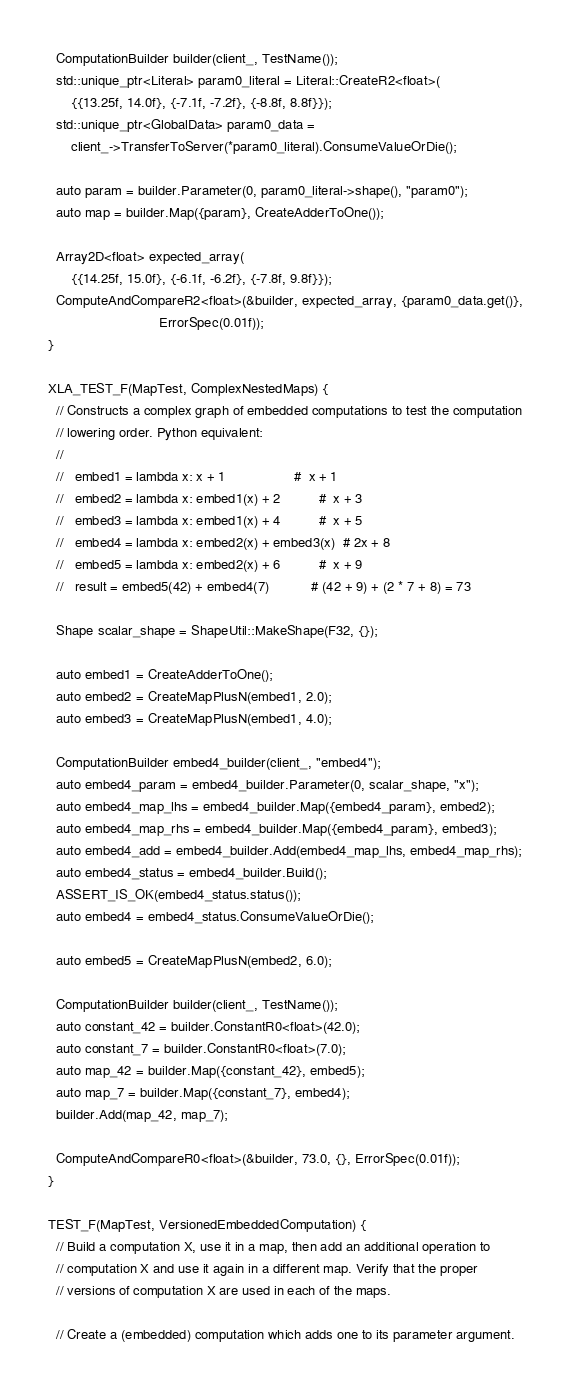<code> <loc_0><loc_0><loc_500><loc_500><_C++_>  ComputationBuilder builder(client_, TestName());
  std::unique_ptr<Literal> param0_literal = Literal::CreateR2<float>(
      {{13.25f, 14.0f}, {-7.1f, -7.2f}, {-8.8f, 8.8f}});
  std::unique_ptr<GlobalData> param0_data =
      client_->TransferToServer(*param0_literal).ConsumeValueOrDie();

  auto param = builder.Parameter(0, param0_literal->shape(), "param0");
  auto map = builder.Map({param}, CreateAdderToOne());

  Array2D<float> expected_array(
      {{14.25f, 15.0f}, {-6.1f, -6.2f}, {-7.8f, 9.8f}});
  ComputeAndCompareR2<float>(&builder, expected_array, {param0_data.get()},
                             ErrorSpec(0.01f));
}

XLA_TEST_F(MapTest, ComplexNestedMaps) {
  // Constructs a complex graph of embedded computations to test the computation
  // lowering order. Python equivalent:
  //
  //   embed1 = lambda x: x + 1                  #  x + 1
  //   embed2 = lambda x: embed1(x) + 2          #  x + 3
  //   embed3 = lambda x: embed1(x) + 4          #  x + 5
  //   embed4 = lambda x: embed2(x) + embed3(x)  # 2x + 8
  //   embed5 = lambda x: embed2(x) + 6          #  x + 9
  //   result = embed5(42) + embed4(7)           # (42 + 9) + (2 * 7 + 8) = 73

  Shape scalar_shape = ShapeUtil::MakeShape(F32, {});

  auto embed1 = CreateAdderToOne();
  auto embed2 = CreateMapPlusN(embed1, 2.0);
  auto embed3 = CreateMapPlusN(embed1, 4.0);

  ComputationBuilder embed4_builder(client_, "embed4");
  auto embed4_param = embed4_builder.Parameter(0, scalar_shape, "x");
  auto embed4_map_lhs = embed4_builder.Map({embed4_param}, embed2);
  auto embed4_map_rhs = embed4_builder.Map({embed4_param}, embed3);
  auto embed4_add = embed4_builder.Add(embed4_map_lhs, embed4_map_rhs);
  auto embed4_status = embed4_builder.Build();
  ASSERT_IS_OK(embed4_status.status());
  auto embed4 = embed4_status.ConsumeValueOrDie();

  auto embed5 = CreateMapPlusN(embed2, 6.0);

  ComputationBuilder builder(client_, TestName());
  auto constant_42 = builder.ConstantR0<float>(42.0);
  auto constant_7 = builder.ConstantR0<float>(7.0);
  auto map_42 = builder.Map({constant_42}, embed5);
  auto map_7 = builder.Map({constant_7}, embed4);
  builder.Add(map_42, map_7);

  ComputeAndCompareR0<float>(&builder, 73.0, {}, ErrorSpec(0.01f));
}

TEST_F(MapTest, VersionedEmbeddedComputation) {
  // Build a computation X, use it in a map, then add an additional operation to
  // computation X and use it again in a different map. Verify that the proper
  // versions of computation X are used in each of the maps.

  // Create a (embedded) computation which adds one to its parameter argument.</code> 